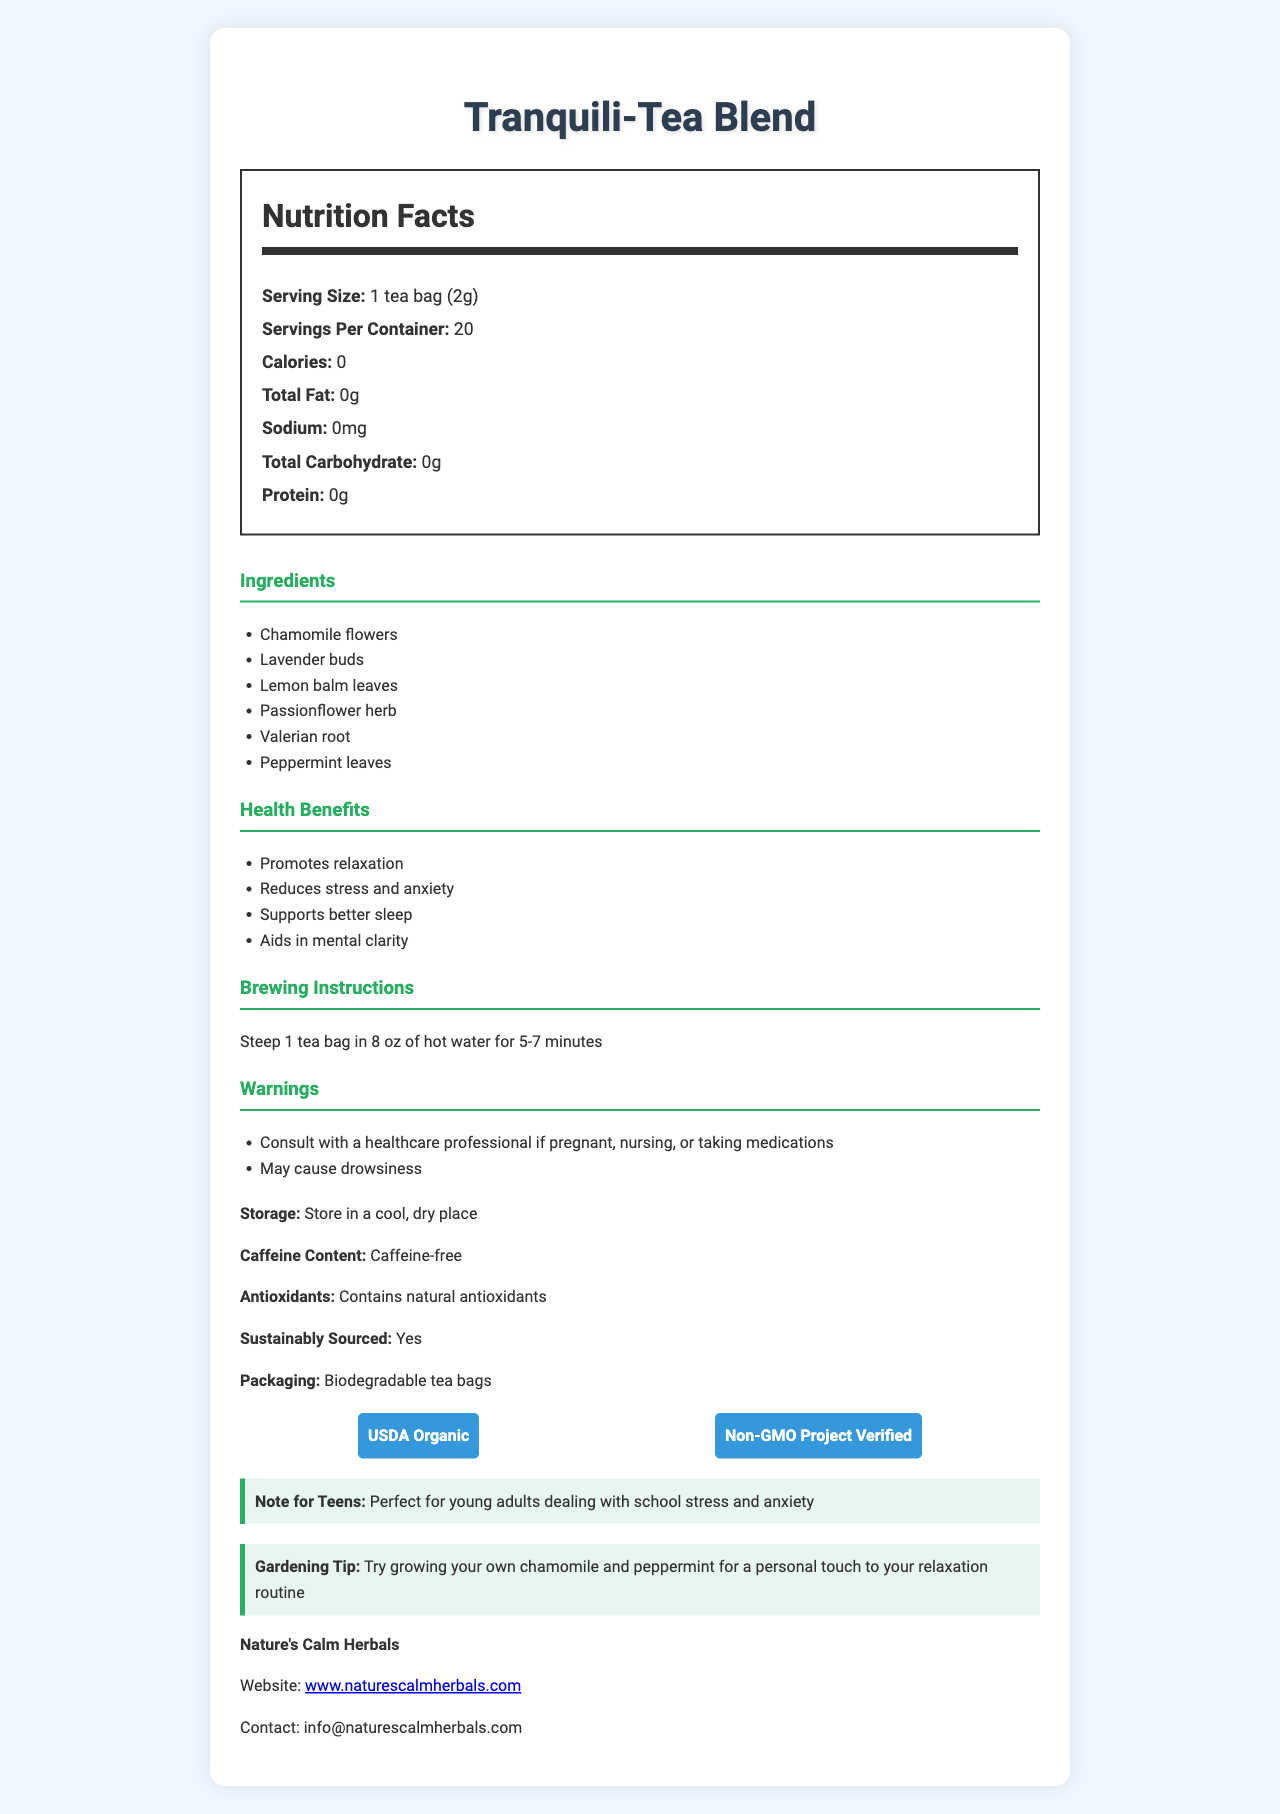What is the name of the herbal tea blend? The name of the product is clearly labeled at the top of the document as "Tranquili-Tea Blend".
Answer: Tranquili-Tea Blend What is the serving size for one tea bag? The serving size is listed in the nutrition facts section as "1 tea bag (2g)".
Answer: 1 tea bag (2g) How many servings are there per container? The document states in the nutrition facts section that there are 20 servings per container.
Answer: 20 What is the calorie count per serving? The document lists the calorie count per serving in the nutrition facts section as 0.
Answer: 0 List two ingredients found in the Tranquili-Tea Blend. The ingredients section of the document lists all the ingredients, with Chamomile flowers and Lavender buds being two of them.
Answer: Chamomile flowers, Lavender buds Does this tea contain any caffeine? The document states that the tea is "Caffeine-free".
Answer: No What is one of the health benefits of this tea? The health benefits section lists multiple benefits, with "Promotes relaxation" being one of them.
Answer: Promotes relaxation Identify the company that produces this tea blend. The footer of the document lists the company's name as "Nature's Calm Herbals".
Answer: Nature's Calm Herbals Where should you store the tea? The storage instructions are listed as "Store in a cool, dry place".
Answer: In a cool, dry place Is this tea certified organic? The document includes a "USDA Organic" certification badge, indicating the tea is organic.
Answer: Yes What are the brewing instructions for this tea? The brewing instructions are provided in the instructions section as "Steep 1 tea bag in 8 oz of hot water for 5-7 minutes".
Answer: Steep 1 tea bag in 8 oz of hot water for 5-7 minutes What should you do if you are pregnant or taking medications? The warnings section advises to "Consult with a healthcare professional if pregnant, nursing, or taking medications".
Answer: Consult with a healthcare professional Describe the main idea of the document. The document serves as a comprehensive guide to the "Tranquili-Tea Blend", highlighting its features and benefits to help potential consumers understand what they are purchasing.
Answer: The document provides detailed information about the "Tranquili-Tea Blend", covering its nutritional facts, ingredients, health benefits, brewing instructions, warnings, storage details, caffeine content, certifications, and company information. It also includes a teen-friendly note and a gardening tip. Which of the following ingredients is NOT in Tranquili-Tea Blend? A. Chamomile flowers B. Green tea leaves C. Valerian root D. Peppermint leaves The ingredients section lists all the ingredients, and Green tea leaves are not among them. The document includes Chamomile flowers, Valerian root, and Peppermint leaves.
Answer: B Which section would you find information about possible drowsiness after consuming the tea? A. Nutrition Facts B. Ingredients C. Warnings D. Certifications The warnings section mentions that the tea "May cause drowsiness".
Answer: C Is the tea sustainably sourced? The document states that the tea is sustainably sourced in the section listing sustainability features.
Answer: Yes How many antioxidants does this tea contain? The document mentions that the tea contains natural antioxidants, but it does not specify the quantity.
Answer: Not enough information What additional note is provided specifically for teenagers? The document includes a "teen-friendly note" stating that the tea is perfect for young adults dealing with school stress and anxiety.
Answer: Perfect for young adults dealing with school stress and anxiety 